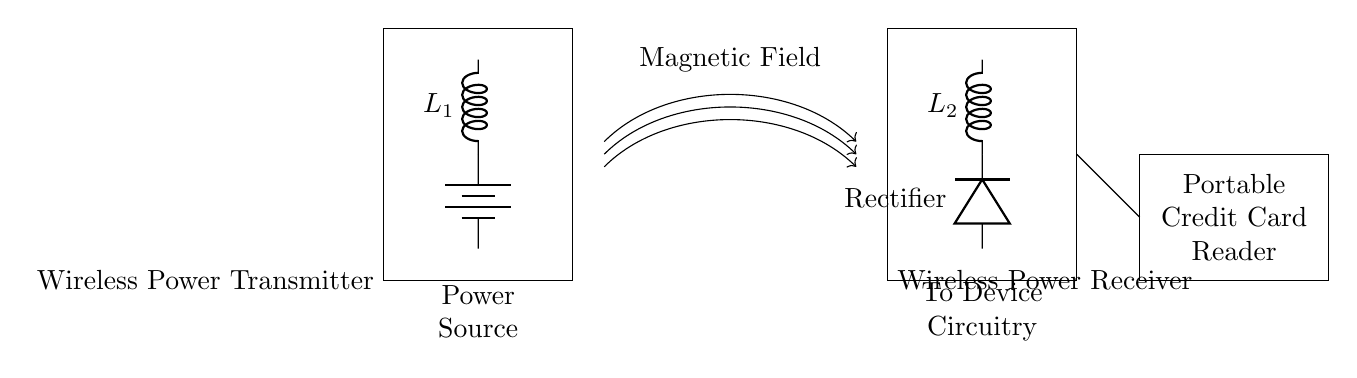What is the power source for the wireless power transmitter? The power source is a battery, as indicated by the component labeled 'battery' in the circuit diagram. It provides the necessary voltage and current to drive the transmitter.
Answer: battery What is the component used to convert alternating current to direct current? The component responsible for this function is a rectifier, as labeled in the circuit diagram connected to the wireless power receiver. It ensures that the portable credit card reader receives the correct type of current for operation.
Answer: Rectifier What does L1 represent in the circuit? L1 represents an inductor, as indicated by the label on the symbol in the wireless power transmitter section. Inductors are used in circuits to store energy in a magnetic field.
Answer: Inductor What is the main purpose of the wireless power receiver? The main purpose of the wireless power receiver is to convert received magnetic energy into electrical energy for use by the portable credit card reader, which highlights its function in this wireless charging setup.
Answer: Convert energy What is the function of the magnetic field in this circuit? The magnetic field transmits energy wirelessly from the transmitter to the receiver, allowing for inductive charging without a physical connection, which is crucial for the operation of portable devices at memorabilia events.
Answer: Energy transmission How does the portable credit card reader connect to the wireless power receiver? The connection is illustrated by the line drawn from the wireless power receiver leading to the credit card reader, indicating that the reader receives power directly from the receiver to function properly.
Answer: Direct connection What component is labeled as L2? L2 is also an inductor, similar to L1, but located in the wireless power receiver section. Inductors are critical for tuning and energy transfer in wireless charging applications.
Answer: Inductor 